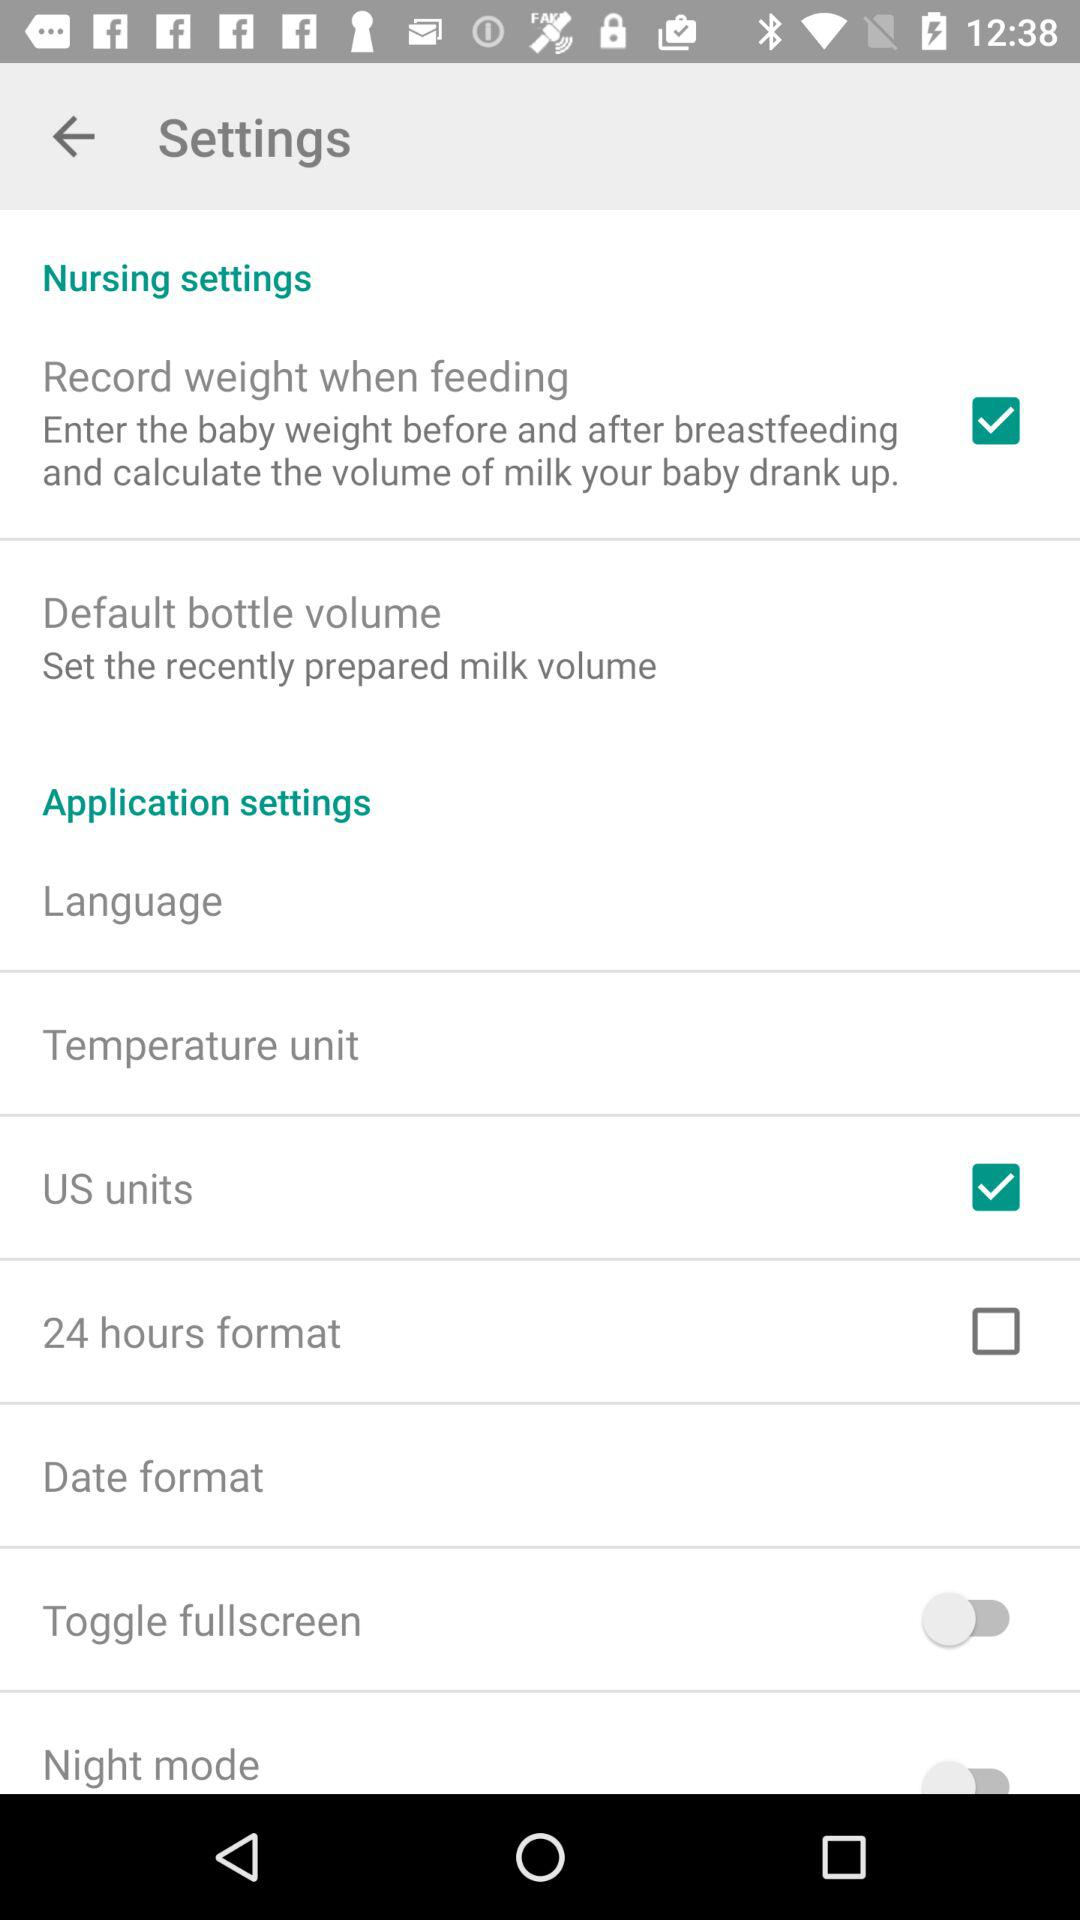What is the status of the "US units"? The status is "on". 